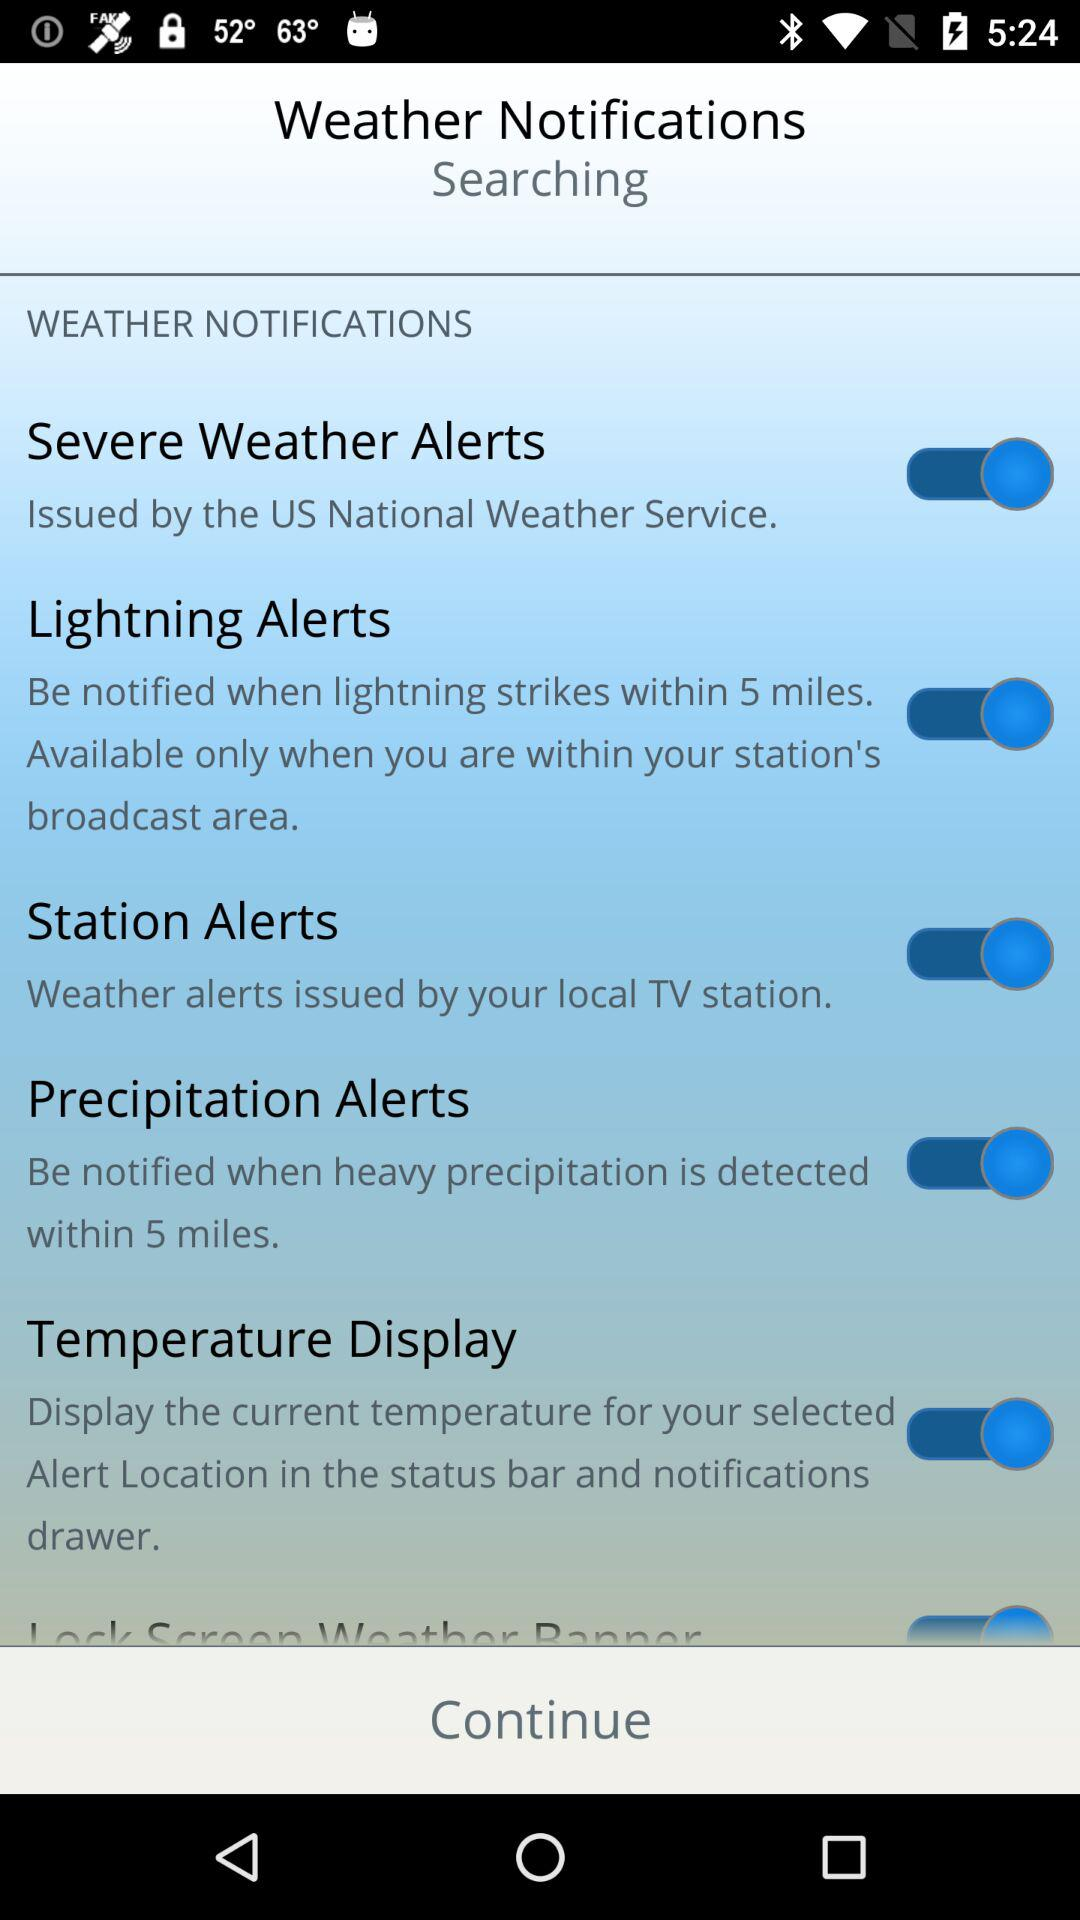What is the status of "Station Alerts"? The status is "on". 